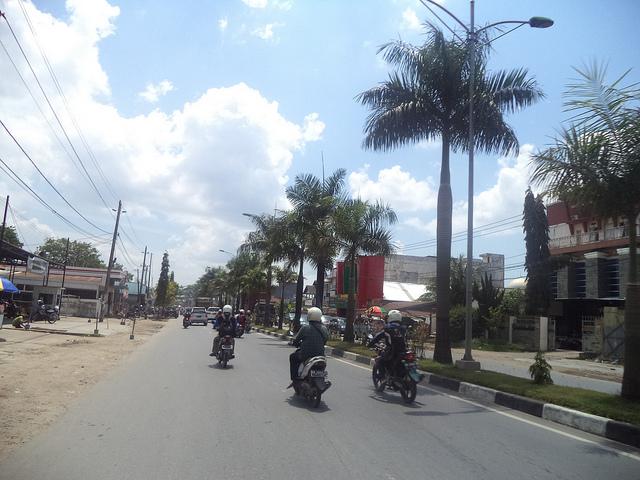Is this a tropical area?
Write a very short answer. Yes. Is this a parade?
Short answer required. No. What kind of trees are they?
Quick response, please. Palm. What is on the back of the bikes?
Quick response, please. Plates. What in on the road?
Concise answer only. Motorcycles. 